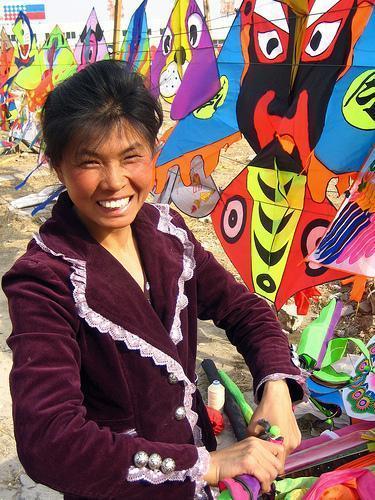How many buttons are visible on the sleeve of the woman's jacket?
Give a very brief answer. 3. How many jackets are there?
Give a very brief answer. 1. How many people are wearing purple?
Give a very brief answer. 1. How many people are wearing blue?
Give a very brief answer. 0. 